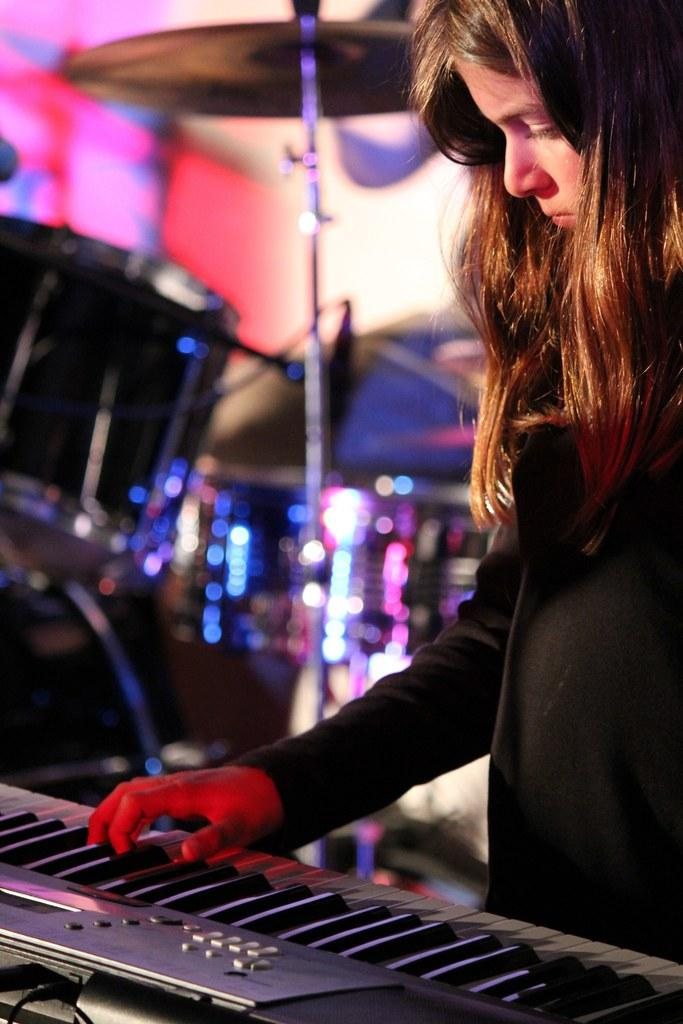Who is present in the image? There is a girl in the image. What musical instruments can be seen in the image? There is a musical keyboard and a drum set in the image. What type of flesh can be seen on the girl's hands in the image? There is no mention of flesh or any specific details about the girl's hands in the image. 